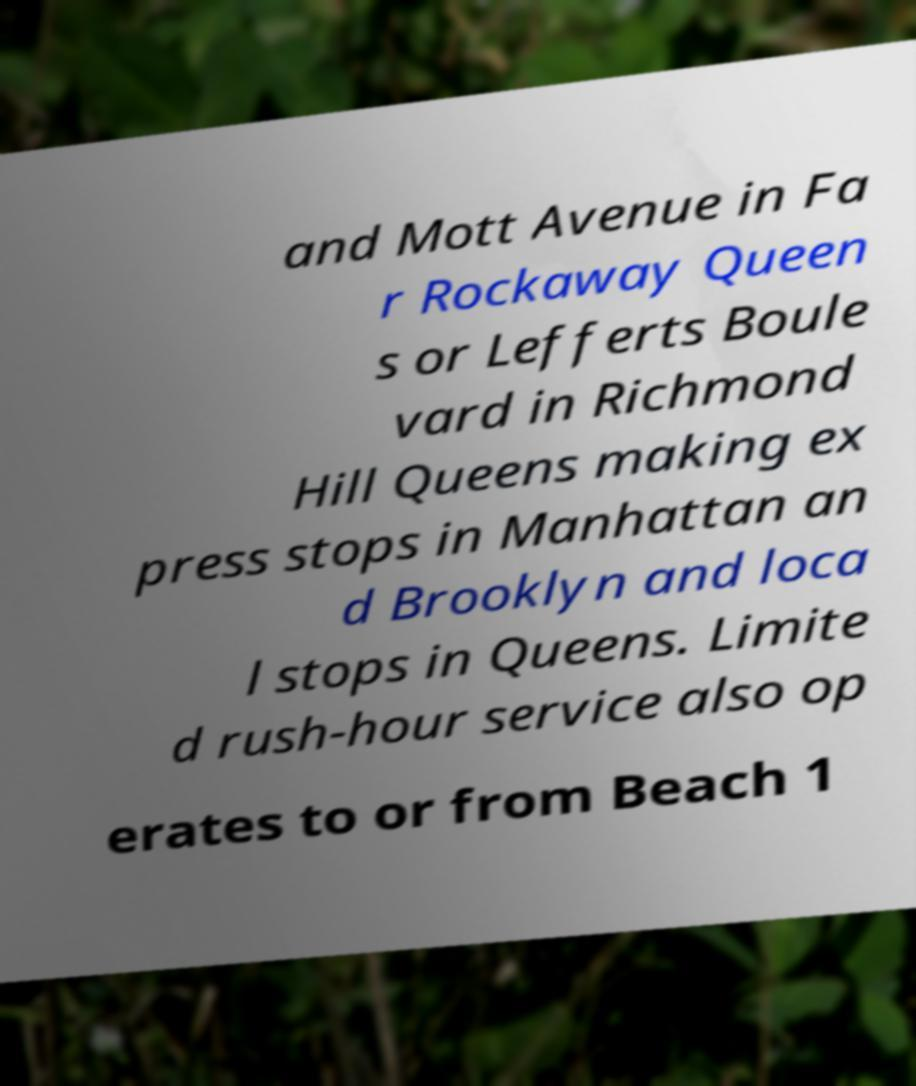Can you read and provide the text displayed in the image?This photo seems to have some interesting text. Can you extract and type it out for me? and Mott Avenue in Fa r Rockaway Queen s or Lefferts Boule vard in Richmond Hill Queens making ex press stops in Manhattan an d Brooklyn and loca l stops in Queens. Limite d rush-hour service also op erates to or from Beach 1 